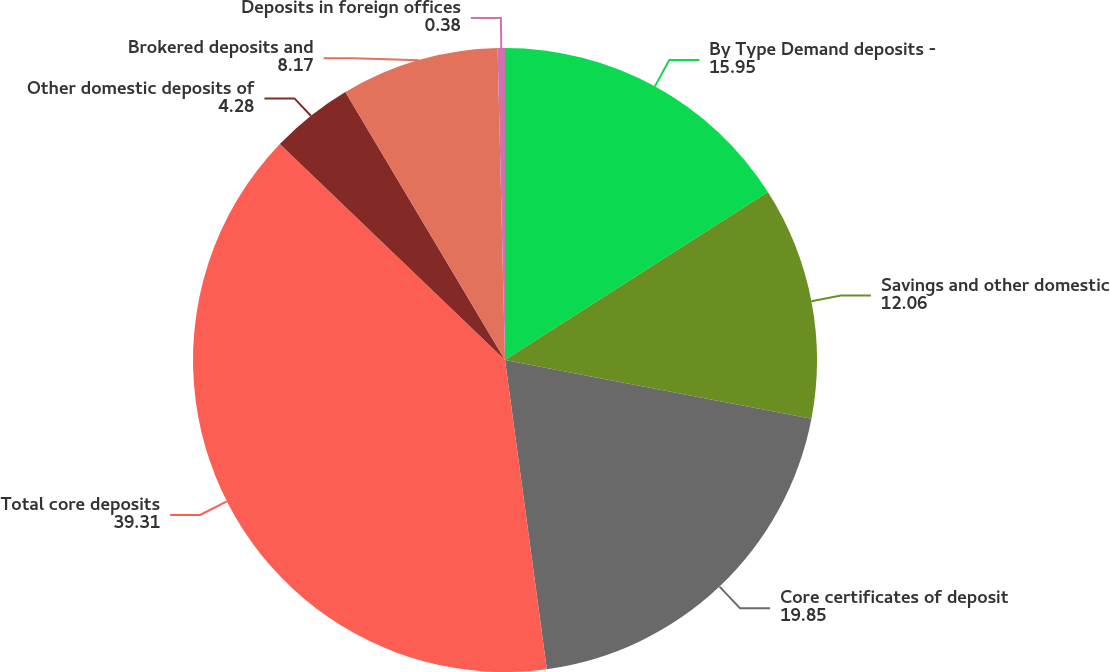Convert chart. <chart><loc_0><loc_0><loc_500><loc_500><pie_chart><fcel>By Type Demand deposits -<fcel>Savings and other domestic<fcel>Core certificates of deposit<fcel>Total core deposits<fcel>Other domestic deposits of<fcel>Brokered deposits and<fcel>Deposits in foreign offices<nl><fcel>15.95%<fcel>12.06%<fcel>19.85%<fcel>39.31%<fcel>4.28%<fcel>8.17%<fcel>0.38%<nl></chart> 